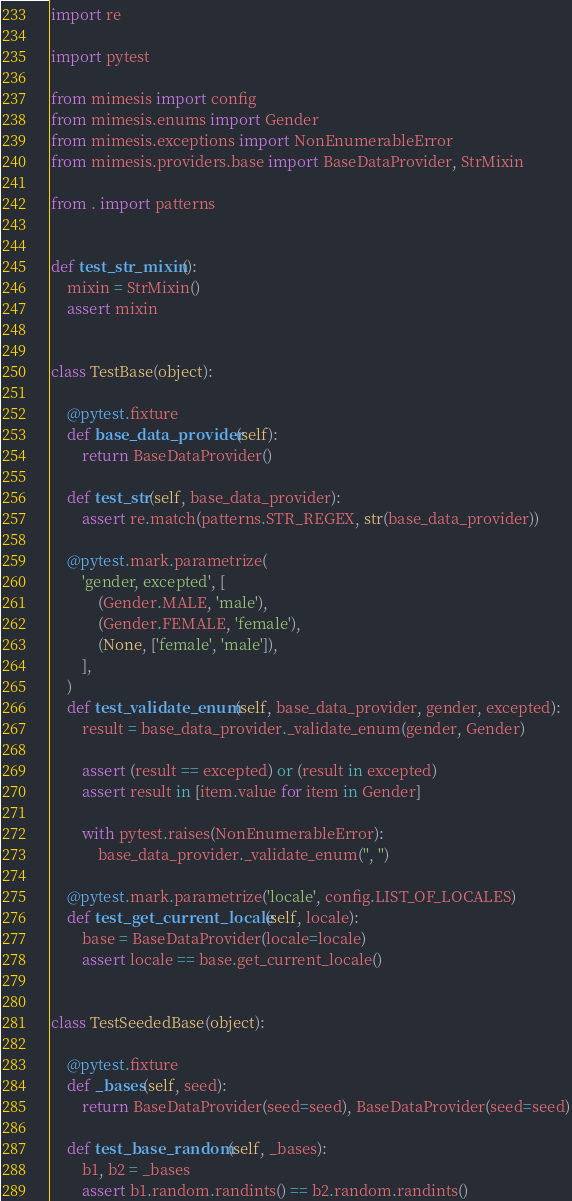Convert code to text. <code><loc_0><loc_0><loc_500><loc_500><_Python_>import re

import pytest

from mimesis import config
from mimesis.enums import Gender
from mimesis.exceptions import NonEnumerableError
from mimesis.providers.base import BaseDataProvider, StrMixin

from . import patterns


def test_str_mixin():
    mixin = StrMixin()
    assert mixin


class TestBase(object):

    @pytest.fixture
    def base_data_provider(self):
        return BaseDataProvider()

    def test_str(self, base_data_provider):
        assert re.match(patterns.STR_REGEX, str(base_data_provider))

    @pytest.mark.parametrize(
        'gender, excepted', [
            (Gender.MALE, 'male'),
            (Gender.FEMALE, 'female'),
            (None, ['female', 'male']),
        ],
    )
    def test_validate_enum(self, base_data_provider, gender, excepted):
        result = base_data_provider._validate_enum(gender, Gender)

        assert (result == excepted) or (result in excepted)
        assert result in [item.value for item in Gender]

        with pytest.raises(NonEnumerableError):
            base_data_provider._validate_enum('', '')

    @pytest.mark.parametrize('locale', config.LIST_OF_LOCALES)
    def test_get_current_locale(self, locale):
        base = BaseDataProvider(locale=locale)
        assert locale == base.get_current_locale()


class TestSeededBase(object):

    @pytest.fixture
    def _bases(self, seed):
        return BaseDataProvider(seed=seed), BaseDataProvider(seed=seed)

    def test_base_random(self, _bases):
        b1, b2 = _bases
        assert b1.random.randints() == b2.random.randints()
</code> 